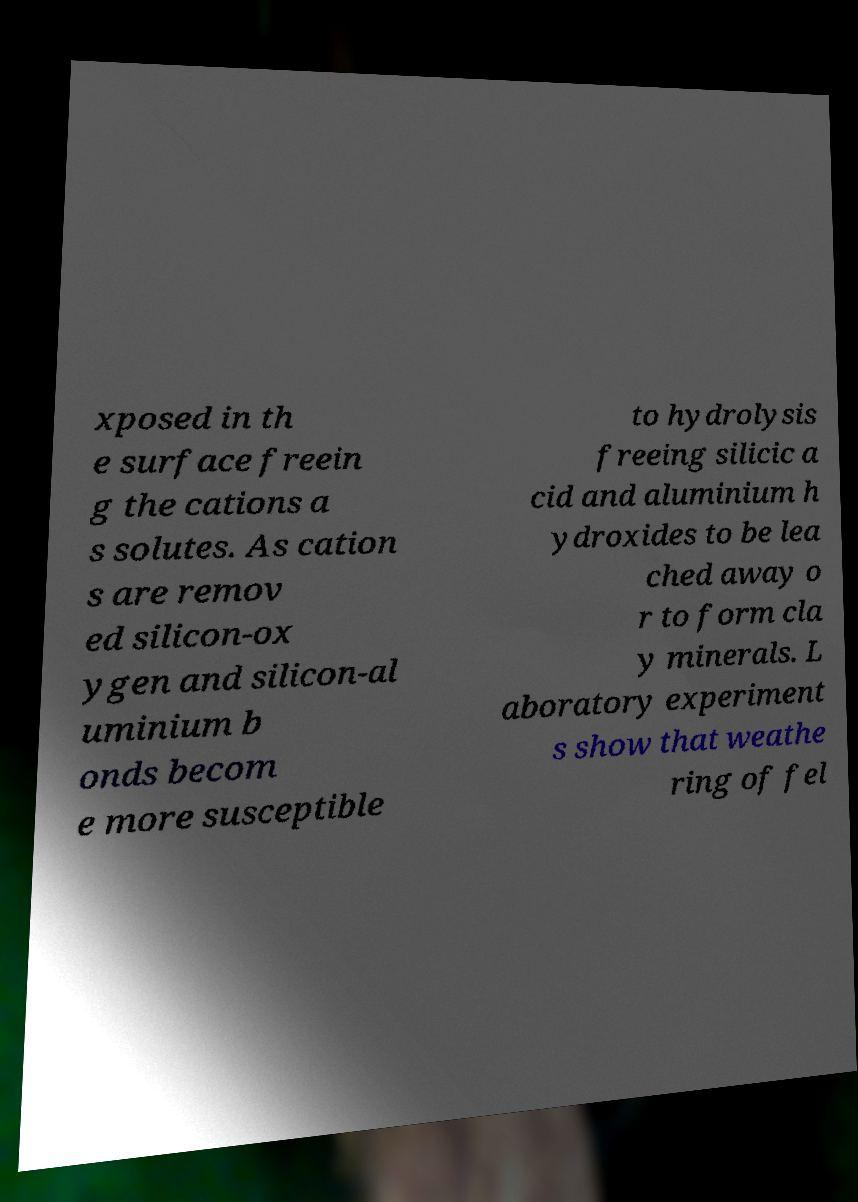Could you extract and type out the text from this image? xposed in th e surface freein g the cations a s solutes. As cation s are remov ed silicon-ox ygen and silicon-al uminium b onds becom e more susceptible to hydrolysis freeing silicic a cid and aluminium h ydroxides to be lea ched away o r to form cla y minerals. L aboratory experiment s show that weathe ring of fel 